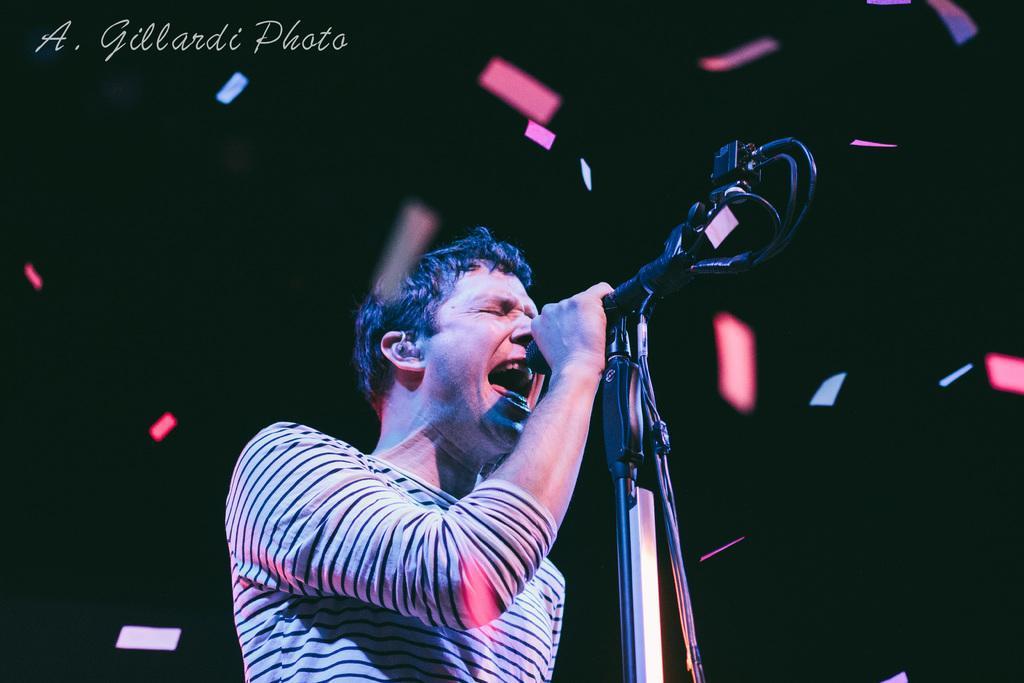In one or two sentences, can you explain what this image depicts? In this image we can see a man standing and holding the mic in his hand. In the background we can see confetti. 